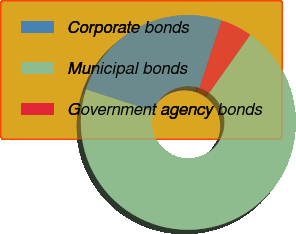Convert chart to OTSL. <chart><loc_0><loc_0><loc_500><loc_500><pie_chart><fcel>Corporate bonds<fcel>Municipal bonds<fcel>Government agency bonds<nl><fcel>25.08%<fcel>70.18%<fcel>4.74%<nl></chart> 